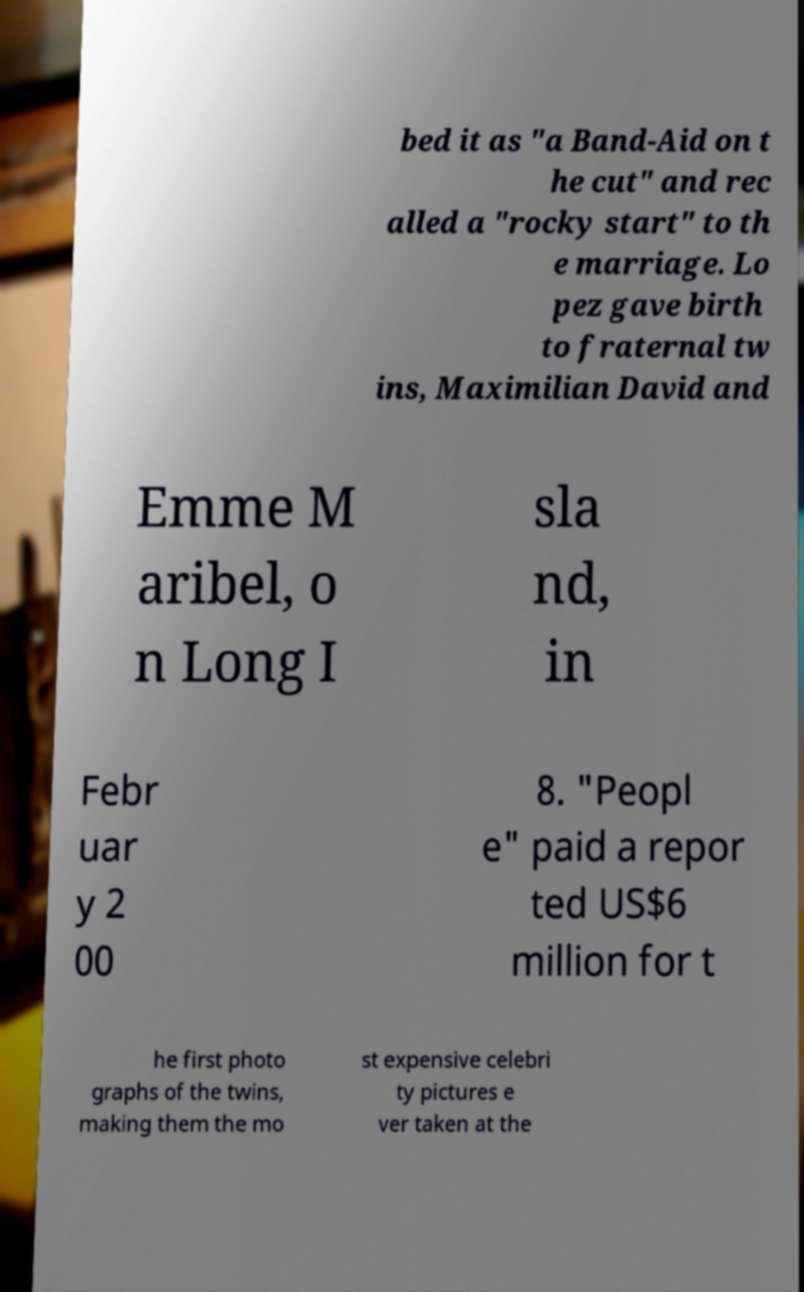Can you accurately transcribe the text from the provided image for me? bed it as "a Band-Aid on t he cut" and rec alled a "rocky start" to th e marriage. Lo pez gave birth to fraternal tw ins, Maximilian David and Emme M aribel, o n Long I sla nd, in Febr uar y 2 00 8. "Peopl e" paid a repor ted US$6 million for t he first photo graphs of the twins, making them the mo st expensive celebri ty pictures e ver taken at the 